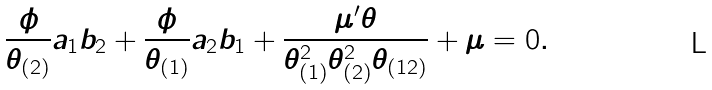Convert formula to latex. <formula><loc_0><loc_0><loc_500><loc_500>\frac { \phi } { \theta _ { ( 2 ) } } a _ { 1 } b _ { 2 } + \frac { \phi } { \theta _ { ( 1 ) } } a _ { 2 } b _ { 1 } + \frac { \mu ^ { \prime } \theta } { \theta _ { ( 1 ) } ^ { 2 } \theta _ { ( 2 ) } ^ { 2 } \theta _ { ( 1 2 ) } } + \mu = 0 .</formula> 